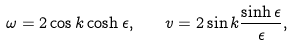<formula> <loc_0><loc_0><loc_500><loc_500>\omega = 2 \cos k \cosh \epsilon , \quad v = 2 \sin k \frac { \sinh \epsilon } { \epsilon } ,</formula> 